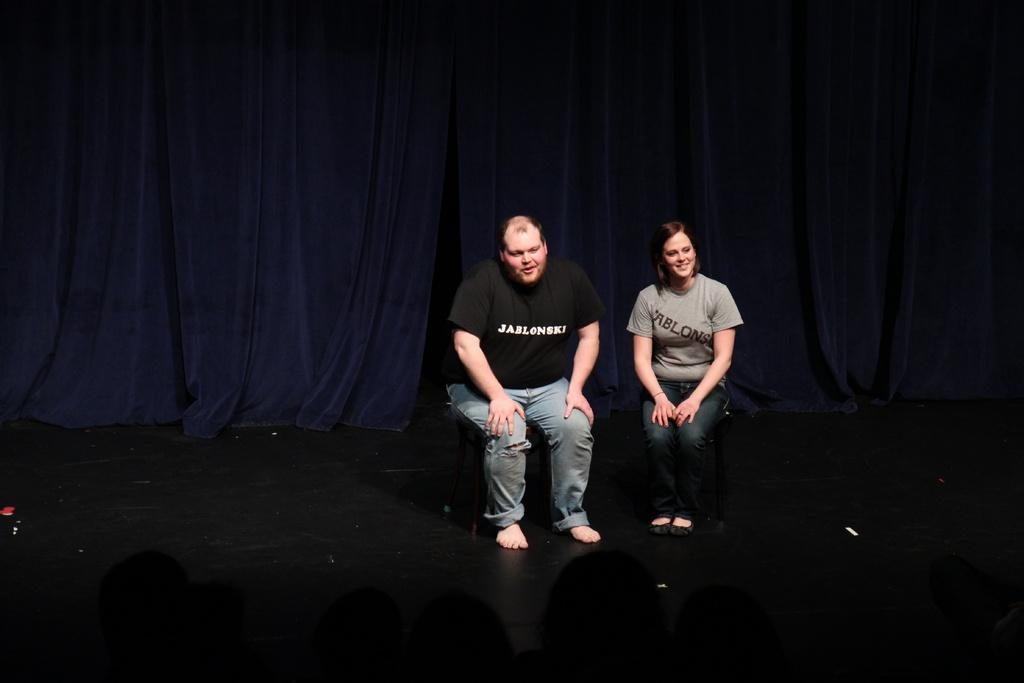How many people are in the image? There are two persons in the image. What are the persons doing in the image? The persons are sitting on chairs. What can be seen in the background of the image? There are curtains in the background of the image. What type of lumber is being used to build the chairs in the image? There is no information about the type of lumber used to build the chairs in the image. 